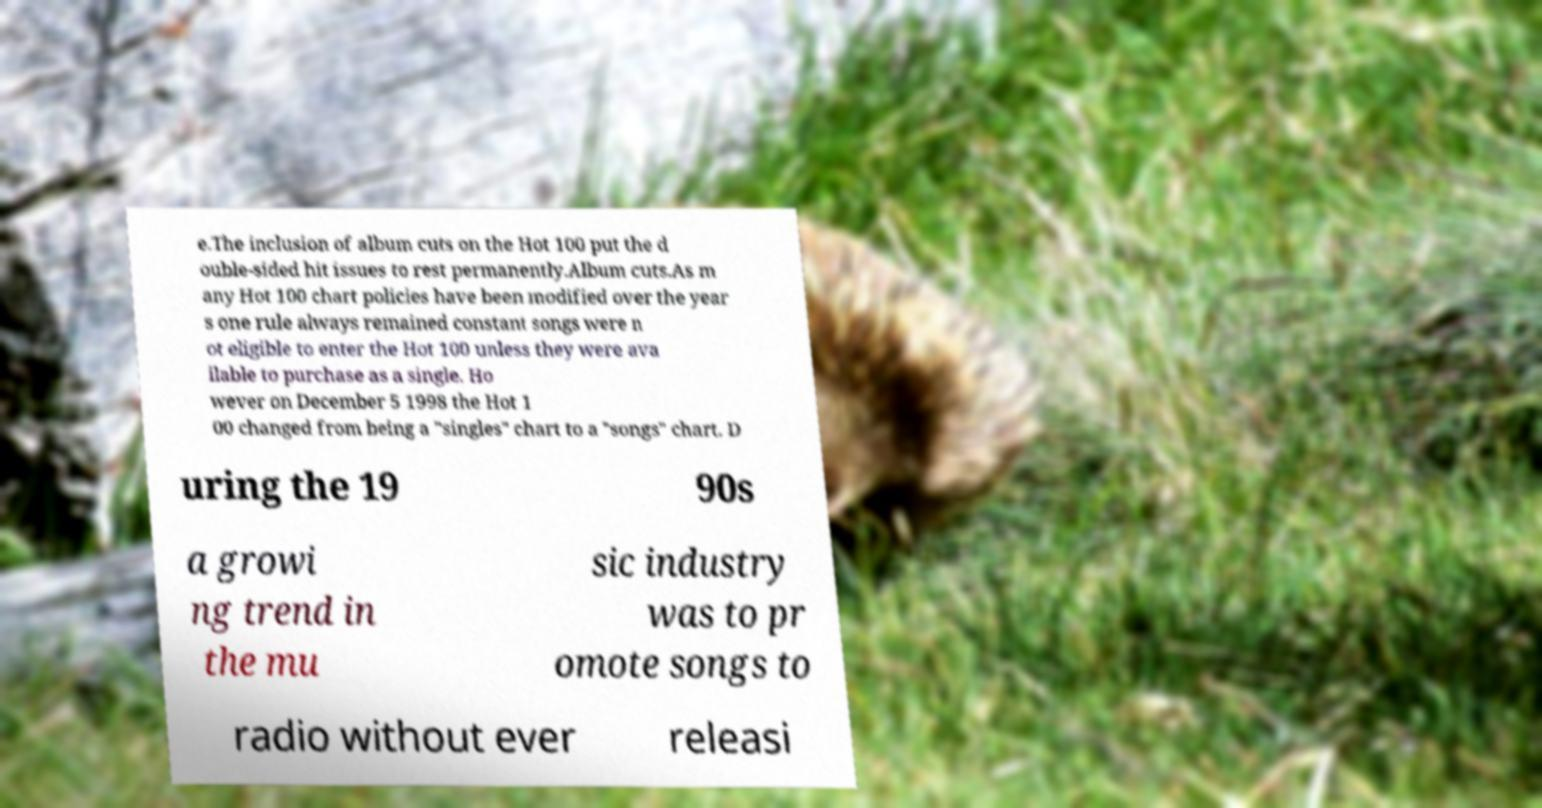What messages or text are displayed in this image? I need them in a readable, typed format. e.The inclusion of album cuts on the Hot 100 put the d ouble-sided hit issues to rest permanently.Album cuts.As m any Hot 100 chart policies have been modified over the year s one rule always remained constant songs were n ot eligible to enter the Hot 100 unless they were ava ilable to purchase as a single. Ho wever on December 5 1998 the Hot 1 00 changed from being a "singles" chart to a "songs" chart. D uring the 19 90s a growi ng trend in the mu sic industry was to pr omote songs to radio without ever releasi 